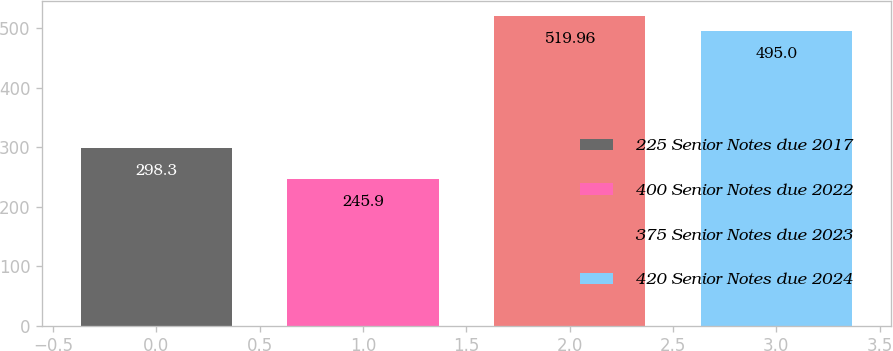Convert chart to OTSL. <chart><loc_0><loc_0><loc_500><loc_500><bar_chart><fcel>225 Senior Notes due 2017<fcel>400 Senior Notes due 2022<fcel>375 Senior Notes due 2023<fcel>420 Senior Notes due 2024<nl><fcel>298.3<fcel>245.9<fcel>519.96<fcel>495<nl></chart> 